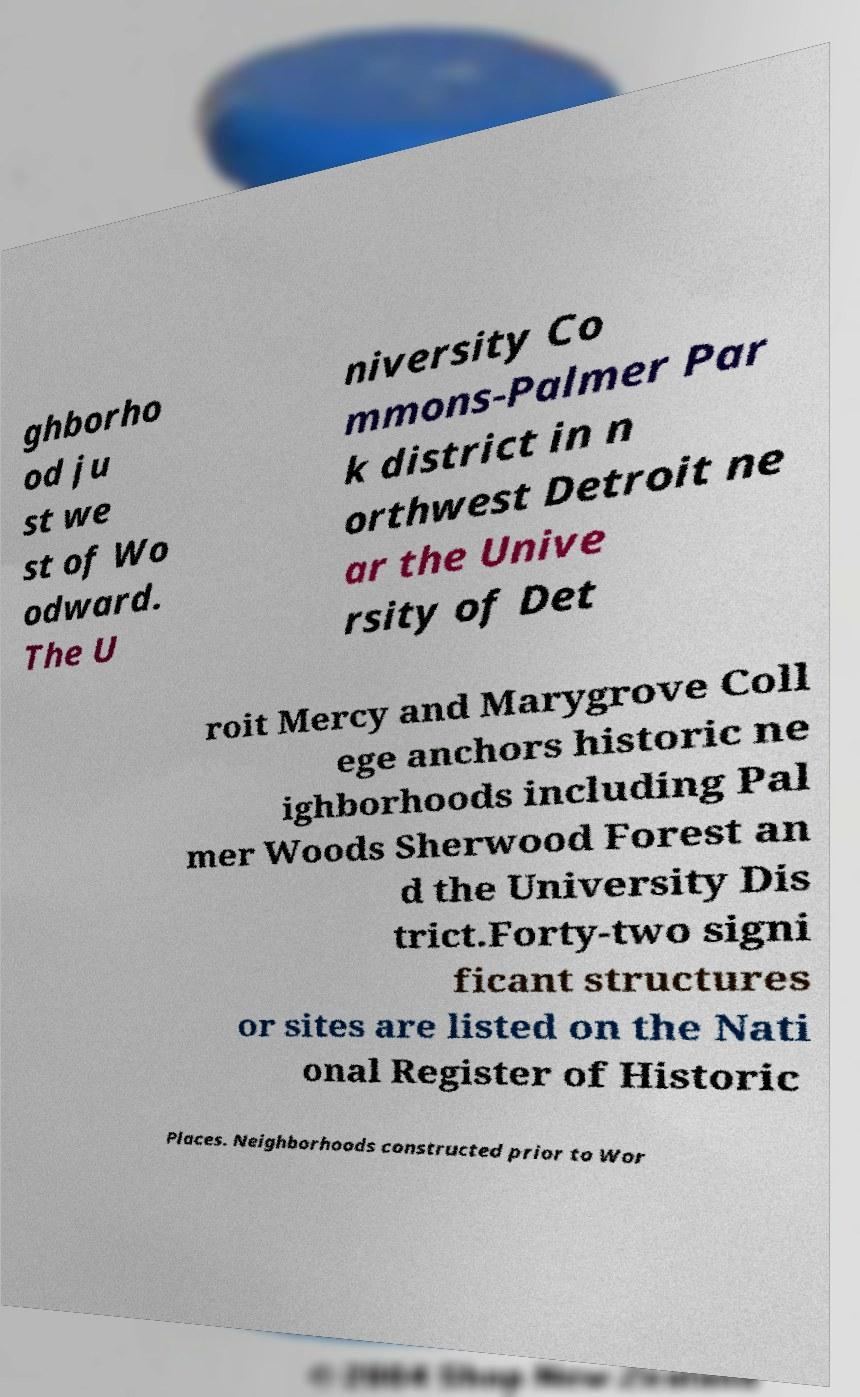There's text embedded in this image that I need extracted. Can you transcribe it verbatim? ghborho od ju st we st of Wo odward. The U niversity Co mmons-Palmer Par k district in n orthwest Detroit ne ar the Unive rsity of Det roit Mercy and Marygrove Coll ege anchors historic ne ighborhoods including Pal mer Woods Sherwood Forest an d the University Dis trict.Forty-two signi ficant structures or sites are listed on the Nati onal Register of Historic Places. Neighborhoods constructed prior to Wor 